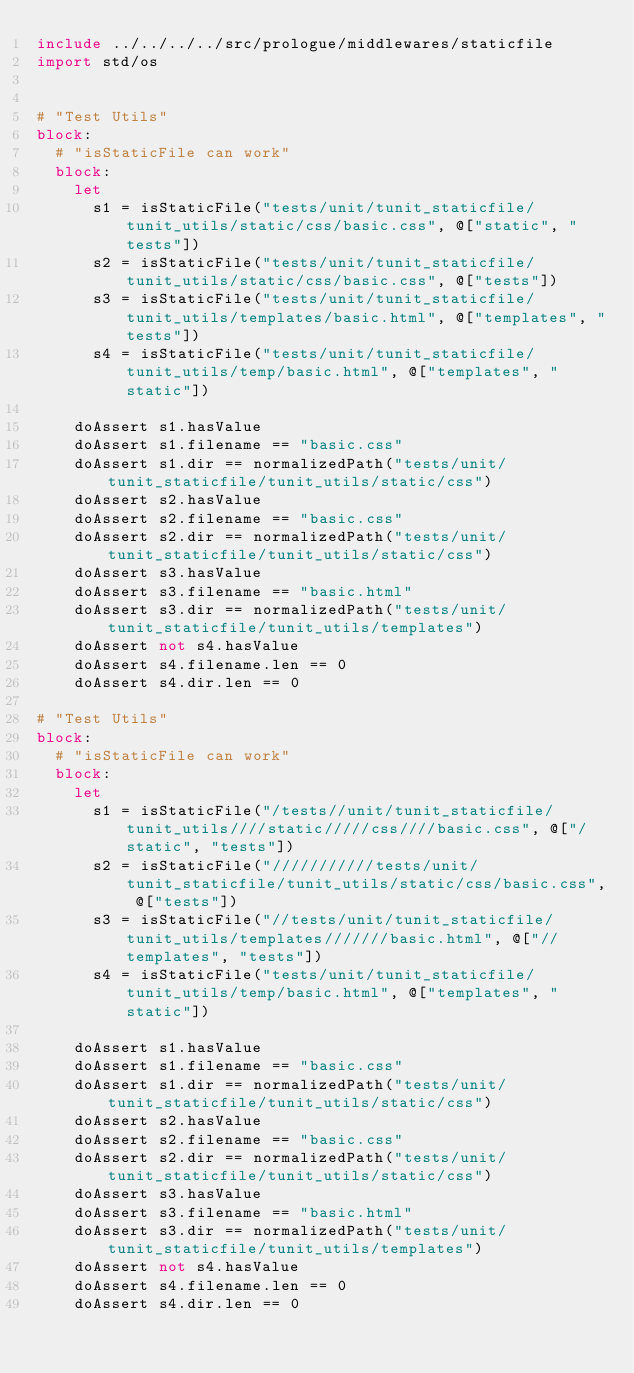<code> <loc_0><loc_0><loc_500><loc_500><_Nim_>include ../../../../src/prologue/middlewares/staticfile
import std/os


# "Test Utils"
block:
  # "isStaticFile can work"
  block:
    let
      s1 = isStaticFile("tests/unit/tunit_staticfile/tunit_utils/static/css/basic.css", @["static", "tests"])
      s2 = isStaticFile("tests/unit/tunit_staticfile/tunit_utils/static/css/basic.css", @["tests"])
      s3 = isStaticFile("tests/unit/tunit_staticfile/tunit_utils/templates/basic.html", @["templates", "tests"])
      s4 = isStaticFile("tests/unit/tunit_staticfile/tunit_utils/temp/basic.html", @["templates", "static"])

    doAssert s1.hasValue
    doAssert s1.filename == "basic.css"
    doAssert s1.dir == normalizedPath("tests/unit/tunit_staticfile/tunit_utils/static/css")
    doAssert s2.hasValue
    doAssert s2.filename == "basic.css"
    doAssert s2.dir == normalizedPath("tests/unit/tunit_staticfile/tunit_utils/static/css")
    doAssert s3.hasValue
    doAssert s3.filename == "basic.html"
    doAssert s3.dir == normalizedPath("tests/unit/tunit_staticfile/tunit_utils/templates")
    doAssert not s4.hasValue
    doAssert s4.filename.len == 0
    doAssert s4.dir.len == 0

# "Test Utils"
block:
  # "isStaticFile can work"
  block:
    let
      s1 = isStaticFile("/tests//unit/tunit_staticfile/tunit_utils////static/////css////basic.css", @["/static", "tests"])
      s2 = isStaticFile("///////////tests/unit/tunit_staticfile/tunit_utils/static/css/basic.css", @["tests"])
      s3 = isStaticFile("//tests/unit/tunit_staticfile/tunit_utils/templates///////basic.html", @["//templates", "tests"])
      s4 = isStaticFile("tests/unit/tunit_staticfile/tunit_utils/temp/basic.html", @["templates", "static"])

    doAssert s1.hasValue
    doAssert s1.filename == "basic.css"
    doAssert s1.dir == normalizedPath("tests/unit/tunit_staticfile/tunit_utils/static/css")
    doAssert s2.hasValue
    doAssert s2.filename == "basic.css"
    doAssert s2.dir == normalizedPath("tests/unit/tunit_staticfile/tunit_utils/static/css")
    doAssert s3.hasValue
    doAssert s3.filename == "basic.html"
    doAssert s3.dir == normalizedPath("tests/unit/tunit_staticfile/tunit_utils/templates")
    doAssert not s4.hasValue
    doAssert s4.filename.len == 0
    doAssert s4.dir.len == 0
</code> 